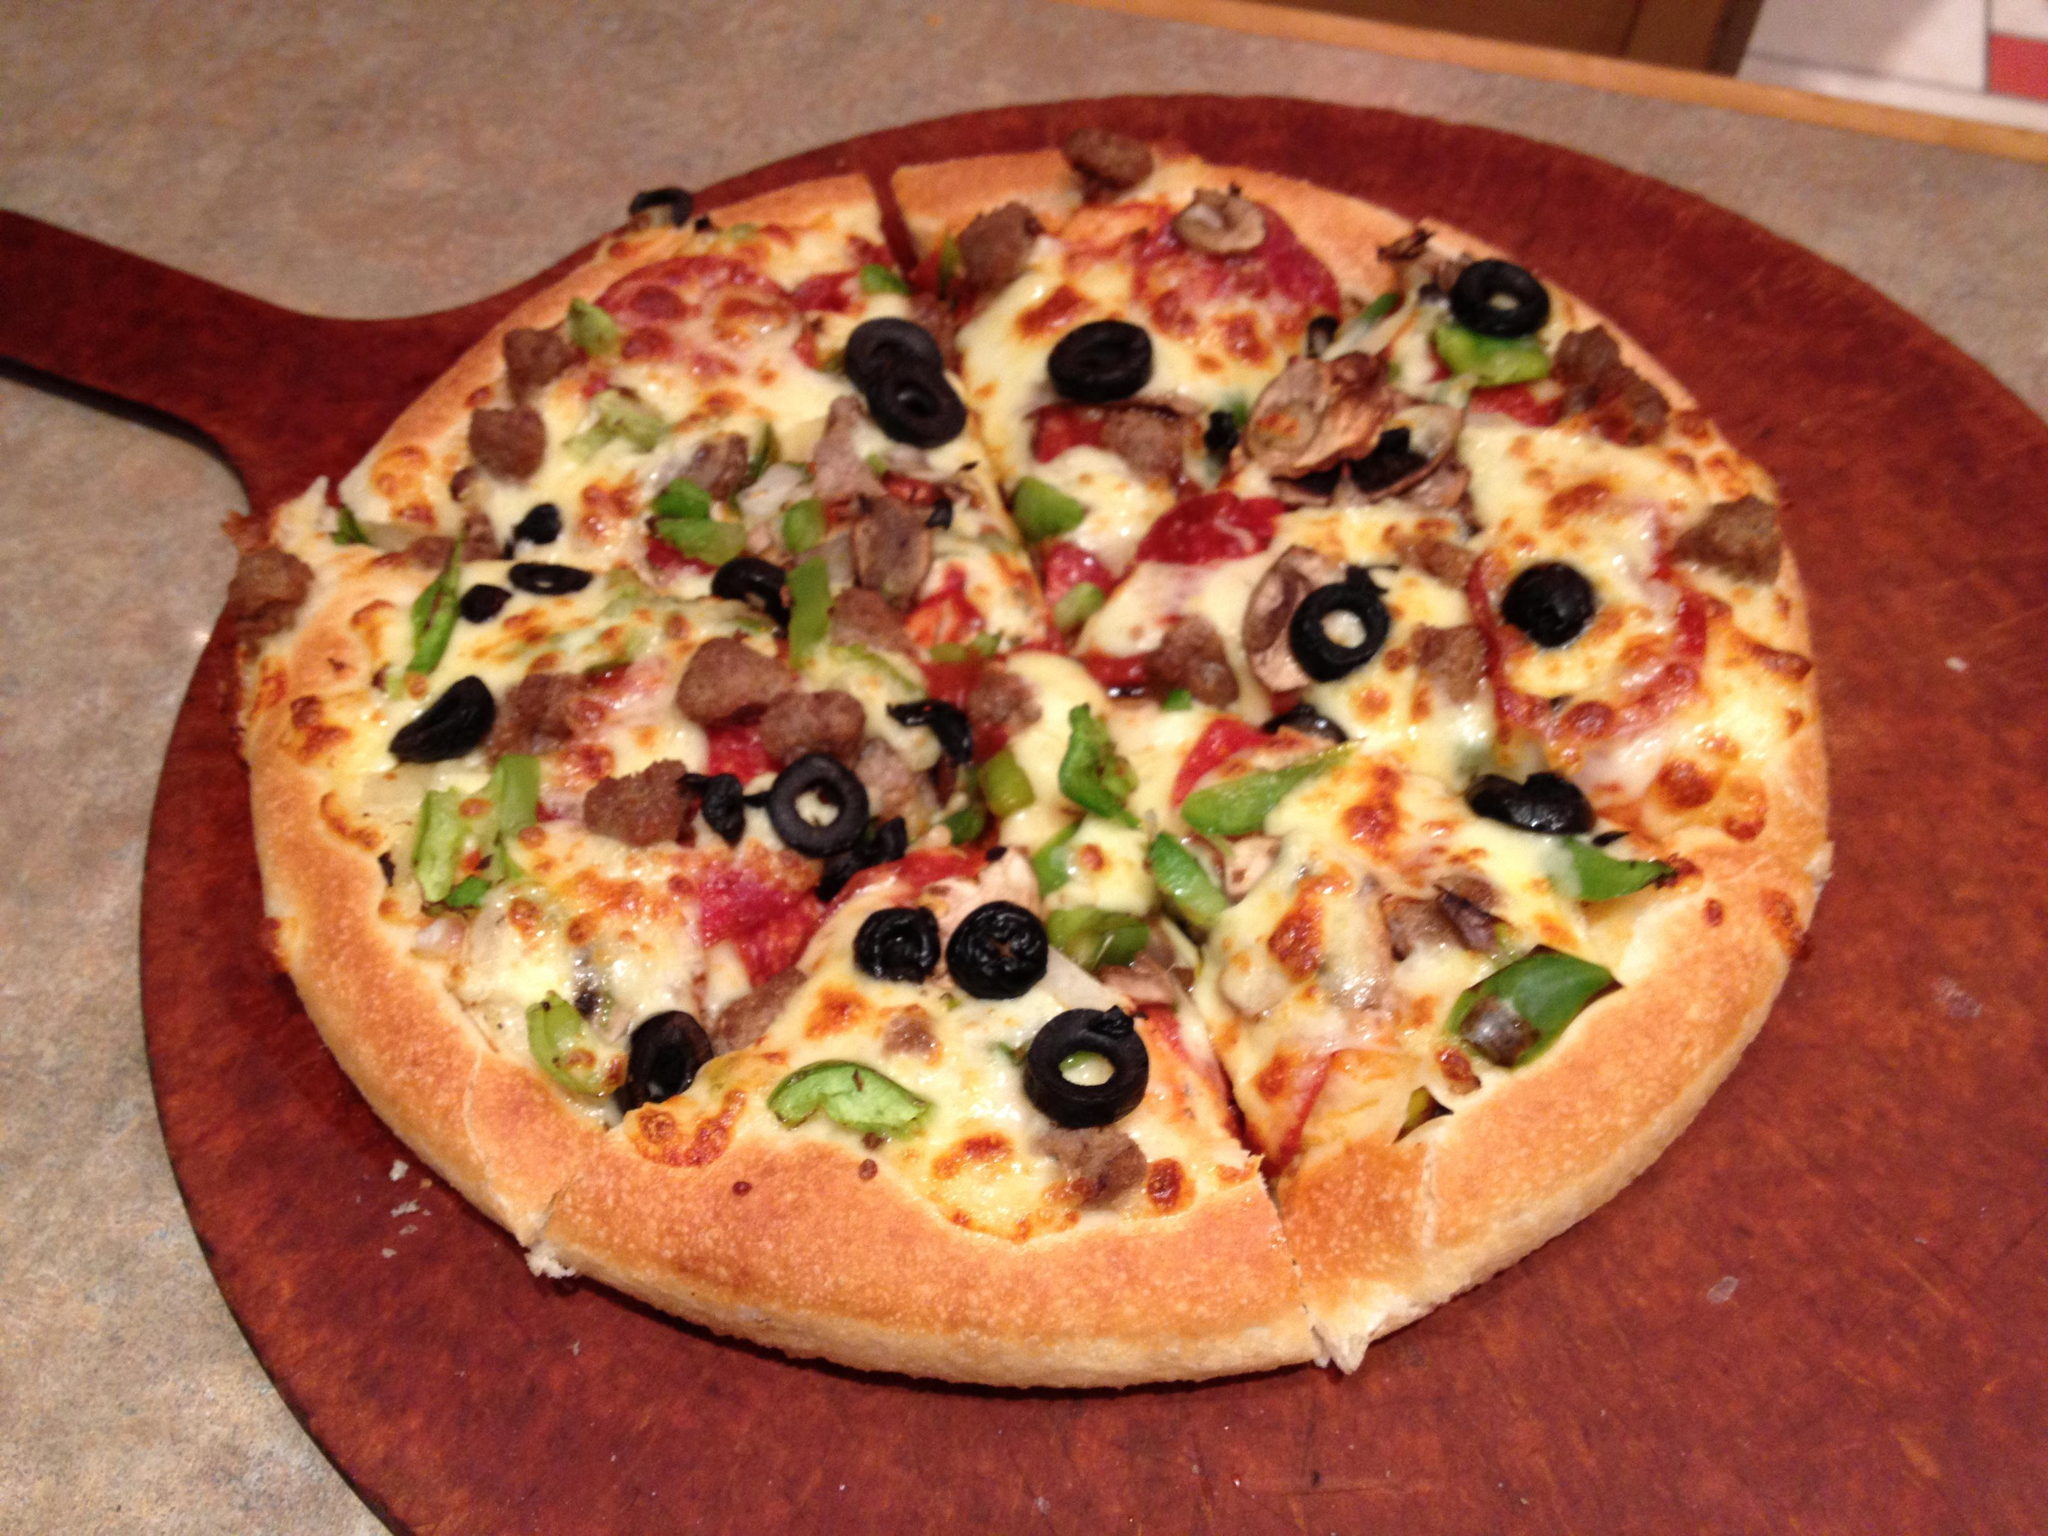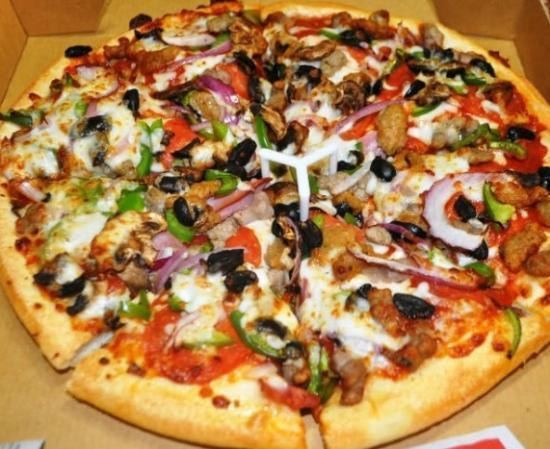The first image is the image on the left, the second image is the image on the right. Assess this claim about the two images: "there is a pizza with a slice being lifted with green peppers on it". Correct or not? Answer yes or no. No. The first image is the image on the left, the second image is the image on the right. Analyze the images presented: Is the assertion "One of the pizzas has a single slice lifted with cheese stretching from it, and the other pizza is sliced but has all slices in place." valid? Answer yes or no. No. 